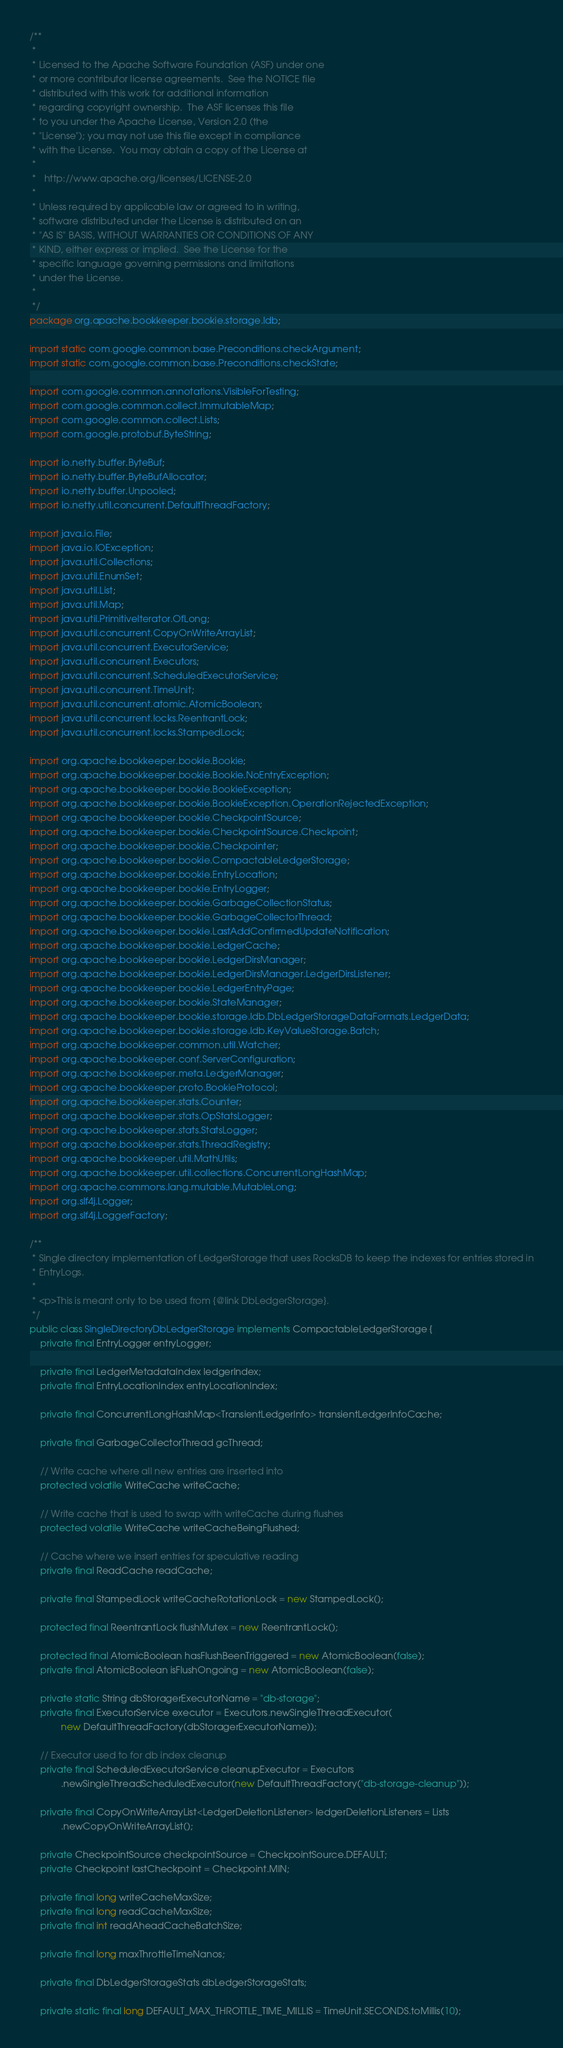<code> <loc_0><loc_0><loc_500><loc_500><_Java_>/**
 *
 * Licensed to the Apache Software Foundation (ASF) under one
 * or more contributor license agreements.  See the NOTICE file
 * distributed with this work for additional information
 * regarding copyright ownership.  The ASF licenses this file
 * to you under the Apache License, Version 2.0 (the
 * "License"); you may not use this file except in compliance
 * with the License.  You may obtain a copy of the License at
 *
 *   http://www.apache.org/licenses/LICENSE-2.0
 *
 * Unless required by applicable law or agreed to in writing,
 * software distributed under the License is distributed on an
 * "AS IS" BASIS, WITHOUT WARRANTIES OR CONDITIONS OF ANY
 * KIND, either express or implied.  See the License for the
 * specific language governing permissions and limitations
 * under the License.
 *
 */
package org.apache.bookkeeper.bookie.storage.ldb;

import static com.google.common.base.Preconditions.checkArgument;
import static com.google.common.base.Preconditions.checkState;

import com.google.common.annotations.VisibleForTesting;
import com.google.common.collect.ImmutableMap;
import com.google.common.collect.Lists;
import com.google.protobuf.ByteString;

import io.netty.buffer.ByteBuf;
import io.netty.buffer.ByteBufAllocator;
import io.netty.buffer.Unpooled;
import io.netty.util.concurrent.DefaultThreadFactory;

import java.io.File;
import java.io.IOException;
import java.util.Collections;
import java.util.EnumSet;
import java.util.List;
import java.util.Map;
import java.util.PrimitiveIterator.OfLong;
import java.util.concurrent.CopyOnWriteArrayList;
import java.util.concurrent.ExecutorService;
import java.util.concurrent.Executors;
import java.util.concurrent.ScheduledExecutorService;
import java.util.concurrent.TimeUnit;
import java.util.concurrent.atomic.AtomicBoolean;
import java.util.concurrent.locks.ReentrantLock;
import java.util.concurrent.locks.StampedLock;

import org.apache.bookkeeper.bookie.Bookie;
import org.apache.bookkeeper.bookie.Bookie.NoEntryException;
import org.apache.bookkeeper.bookie.BookieException;
import org.apache.bookkeeper.bookie.BookieException.OperationRejectedException;
import org.apache.bookkeeper.bookie.CheckpointSource;
import org.apache.bookkeeper.bookie.CheckpointSource.Checkpoint;
import org.apache.bookkeeper.bookie.Checkpointer;
import org.apache.bookkeeper.bookie.CompactableLedgerStorage;
import org.apache.bookkeeper.bookie.EntryLocation;
import org.apache.bookkeeper.bookie.EntryLogger;
import org.apache.bookkeeper.bookie.GarbageCollectionStatus;
import org.apache.bookkeeper.bookie.GarbageCollectorThread;
import org.apache.bookkeeper.bookie.LastAddConfirmedUpdateNotification;
import org.apache.bookkeeper.bookie.LedgerCache;
import org.apache.bookkeeper.bookie.LedgerDirsManager;
import org.apache.bookkeeper.bookie.LedgerDirsManager.LedgerDirsListener;
import org.apache.bookkeeper.bookie.LedgerEntryPage;
import org.apache.bookkeeper.bookie.StateManager;
import org.apache.bookkeeper.bookie.storage.ldb.DbLedgerStorageDataFormats.LedgerData;
import org.apache.bookkeeper.bookie.storage.ldb.KeyValueStorage.Batch;
import org.apache.bookkeeper.common.util.Watcher;
import org.apache.bookkeeper.conf.ServerConfiguration;
import org.apache.bookkeeper.meta.LedgerManager;
import org.apache.bookkeeper.proto.BookieProtocol;
import org.apache.bookkeeper.stats.Counter;
import org.apache.bookkeeper.stats.OpStatsLogger;
import org.apache.bookkeeper.stats.StatsLogger;
import org.apache.bookkeeper.stats.ThreadRegistry;
import org.apache.bookkeeper.util.MathUtils;
import org.apache.bookkeeper.util.collections.ConcurrentLongHashMap;
import org.apache.commons.lang.mutable.MutableLong;
import org.slf4j.Logger;
import org.slf4j.LoggerFactory;

/**
 * Single directory implementation of LedgerStorage that uses RocksDB to keep the indexes for entries stored in
 * EntryLogs.
 *
 * <p>This is meant only to be used from {@link DbLedgerStorage}.
 */
public class SingleDirectoryDbLedgerStorage implements CompactableLedgerStorage {
    private final EntryLogger entryLogger;

    private final LedgerMetadataIndex ledgerIndex;
    private final EntryLocationIndex entryLocationIndex;

    private final ConcurrentLongHashMap<TransientLedgerInfo> transientLedgerInfoCache;

    private final GarbageCollectorThread gcThread;

    // Write cache where all new entries are inserted into
    protected volatile WriteCache writeCache;

    // Write cache that is used to swap with writeCache during flushes
    protected volatile WriteCache writeCacheBeingFlushed;

    // Cache where we insert entries for speculative reading
    private final ReadCache readCache;

    private final StampedLock writeCacheRotationLock = new StampedLock();

    protected final ReentrantLock flushMutex = new ReentrantLock();

    protected final AtomicBoolean hasFlushBeenTriggered = new AtomicBoolean(false);
    private final AtomicBoolean isFlushOngoing = new AtomicBoolean(false);

    private static String dbStoragerExecutorName = "db-storage";
    private final ExecutorService executor = Executors.newSingleThreadExecutor(
            new DefaultThreadFactory(dbStoragerExecutorName));

    // Executor used to for db index cleanup
    private final ScheduledExecutorService cleanupExecutor = Executors
            .newSingleThreadScheduledExecutor(new DefaultThreadFactory("db-storage-cleanup"));

    private final CopyOnWriteArrayList<LedgerDeletionListener> ledgerDeletionListeners = Lists
            .newCopyOnWriteArrayList();

    private CheckpointSource checkpointSource = CheckpointSource.DEFAULT;
    private Checkpoint lastCheckpoint = Checkpoint.MIN;

    private final long writeCacheMaxSize;
    private final long readCacheMaxSize;
    private final int readAheadCacheBatchSize;

    private final long maxThrottleTimeNanos;

    private final DbLedgerStorageStats dbLedgerStorageStats;

    private static final long DEFAULT_MAX_THROTTLE_TIME_MILLIS = TimeUnit.SECONDS.toMillis(10);
</code> 